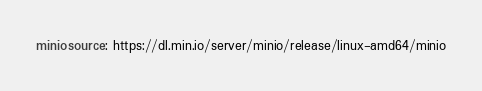<code> <loc_0><loc_0><loc_500><loc_500><_YAML_>miniosource: https://dl.min.io/server/minio/release/linux-amd64/minio
</code> 